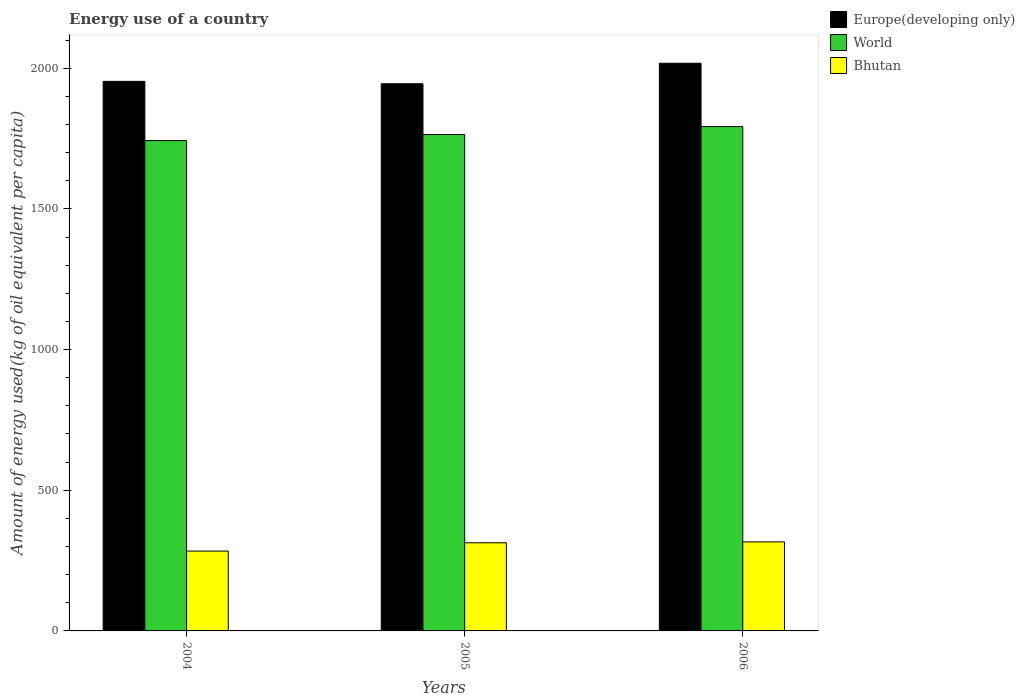How many different coloured bars are there?
Make the answer very short. 3. Are the number of bars on each tick of the X-axis equal?
Offer a very short reply. Yes. How many bars are there on the 1st tick from the right?
Provide a short and direct response. 3. What is the label of the 1st group of bars from the left?
Offer a terse response. 2004. In how many cases, is the number of bars for a given year not equal to the number of legend labels?
Your response must be concise. 0. What is the amount of energy used in in Europe(developing only) in 2005?
Your answer should be very brief. 1944.76. Across all years, what is the maximum amount of energy used in in World?
Your answer should be compact. 1792.57. Across all years, what is the minimum amount of energy used in in Bhutan?
Offer a terse response. 283.81. In which year was the amount of energy used in in World maximum?
Your response must be concise. 2006. What is the total amount of energy used in in World in the graph?
Ensure brevity in your answer.  5299.55. What is the difference between the amount of energy used in in Europe(developing only) in 2004 and that in 2005?
Offer a very short reply. 8.48. What is the difference between the amount of energy used in in World in 2005 and the amount of energy used in in Europe(developing only) in 2006?
Your answer should be compact. -253.32. What is the average amount of energy used in in Bhutan per year?
Keep it short and to the point. 304.49. In the year 2005, what is the difference between the amount of energy used in in Europe(developing only) and amount of energy used in in Bhutan?
Make the answer very short. 1631.47. In how many years, is the amount of energy used in in Bhutan greater than 2000 kg?
Your answer should be very brief. 0. What is the ratio of the amount of energy used in in Bhutan in 2004 to that in 2006?
Provide a short and direct response. 0.9. Is the amount of energy used in in Bhutan in 2005 less than that in 2006?
Provide a succinct answer. Yes. Is the difference between the amount of energy used in in Europe(developing only) in 2004 and 2006 greater than the difference between the amount of energy used in in Bhutan in 2004 and 2006?
Offer a very short reply. No. What is the difference between the highest and the second highest amount of energy used in in World?
Your response must be concise. 28.32. What is the difference between the highest and the lowest amount of energy used in in Europe(developing only)?
Offer a terse response. 72.82. What does the 3rd bar from the left in 2005 represents?
Your answer should be compact. Bhutan. Is it the case that in every year, the sum of the amount of energy used in in Europe(developing only) and amount of energy used in in Bhutan is greater than the amount of energy used in in World?
Offer a terse response. Yes. How many bars are there?
Provide a short and direct response. 9. What is the difference between two consecutive major ticks on the Y-axis?
Your answer should be very brief. 500. Are the values on the major ticks of Y-axis written in scientific E-notation?
Make the answer very short. No. Does the graph contain any zero values?
Keep it short and to the point. No. Does the graph contain grids?
Ensure brevity in your answer.  No. Where does the legend appear in the graph?
Your answer should be compact. Top right. How many legend labels are there?
Your response must be concise. 3. What is the title of the graph?
Give a very brief answer. Energy use of a country. What is the label or title of the X-axis?
Your answer should be very brief. Years. What is the label or title of the Y-axis?
Your answer should be very brief. Amount of energy used(kg of oil equivalent per capita). What is the Amount of energy used(kg of oil equivalent per capita) of Europe(developing only) in 2004?
Your response must be concise. 1953.24. What is the Amount of energy used(kg of oil equivalent per capita) in World in 2004?
Your answer should be compact. 1742.71. What is the Amount of energy used(kg of oil equivalent per capita) in Bhutan in 2004?
Ensure brevity in your answer.  283.81. What is the Amount of energy used(kg of oil equivalent per capita) of Europe(developing only) in 2005?
Keep it short and to the point. 1944.76. What is the Amount of energy used(kg of oil equivalent per capita) of World in 2005?
Ensure brevity in your answer.  1764.26. What is the Amount of energy used(kg of oil equivalent per capita) in Bhutan in 2005?
Keep it short and to the point. 313.29. What is the Amount of energy used(kg of oil equivalent per capita) in Europe(developing only) in 2006?
Your response must be concise. 2017.58. What is the Amount of energy used(kg of oil equivalent per capita) in World in 2006?
Your response must be concise. 1792.57. What is the Amount of energy used(kg of oil equivalent per capita) of Bhutan in 2006?
Provide a succinct answer. 316.38. Across all years, what is the maximum Amount of energy used(kg of oil equivalent per capita) in Europe(developing only)?
Make the answer very short. 2017.58. Across all years, what is the maximum Amount of energy used(kg of oil equivalent per capita) in World?
Your answer should be compact. 1792.57. Across all years, what is the maximum Amount of energy used(kg of oil equivalent per capita) in Bhutan?
Provide a succinct answer. 316.38. Across all years, what is the minimum Amount of energy used(kg of oil equivalent per capita) of Europe(developing only)?
Make the answer very short. 1944.76. Across all years, what is the minimum Amount of energy used(kg of oil equivalent per capita) of World?
Provide a succinct answer. 1742.71. Across all years, what is the minimum Amount of energy used(kg of oil equivalent per capita) of Bhutan?
Make the answer very short. 283.81. What is the total Amount of energy used(kg of oil equivalent per capita) in Europe(developing only) in the graph?
Your response must be concise. 5915.57. What is the total Amount of energy used(kg of oil equivalent per capita) of World in the graph?
Keep it short and to the point. 5299.55. What is the total Amount of energy used(kg of oil equivalent per capita) in Bhutan in the graph?
Give a very brief answer. 913.47. What is the difference between the Amount of energy used(kg of oil equivalent per capita) in Europe(developing only) in 2004 and that in 2005?
Your answer should be very brief. 8.48. What is the difference between the Amount of energy used(kg of oil equivalent per capita) of World in 2004 and that in 2005?
Offer a terse response. -21.54. What is the difference between the Amount of energy used(kg of oil equivalent per capita) of Bhutan in 2004 and that in 2005?
Keep it short and to the point. -29.48. What is the difference between the Amount of energy used(kg of oil equivalent per capita) in Europe(developing only) in 2004 and that in 2006?
Make the answer very short. -64.34. What is the difference between the Amount of energy used(kg of oil equivalent per capita) in World in 2004 and that in 2006?
Ensure brevity in your answer.  -49.86. What is the difference between the Amount of energy used(kg of oil equivalent per capita) of Bhutan in 2004 and that in 2006?
Make the answer very short. -32.57. What is the difference between the Amount of energy used(kg of oil equivalent per capita) of Europe(developing only) in 2005 and that in 2006?
Your answer should be very brief. -72.82. What is the difference between the Amount of energy used(kg of oil equivalent per capita) of World in 2005 and that in 2006?
Ensure brevity in your answer.  -28.32. What is the difference between the Amount of energy used(kg of oil equivalent per capita) in Bhutan in 2005 and that in 2006?
Ensure brevity in your answer.  -3.09. What is the difference between the Amount of energy used(kg of oil equivalent per capita) in Europe(developing only) in 2004 and the Amount of energy used(kg of oil equivalent per capita) in World in 2005?
Offer a terse response. 188.98. What is the difference between the Amount of energy used(kg of oil equivalent per capita) of Europe(developing only) in 2004 and the Amount of energy used(kg of oil equivalent per capita) of Bhutan in 2005?
Ensure brevity in your answer.  1639.95. What is the difference between the Amount of energy used(kg of oil equivalent per capita) in World in 2004 and the Amount of energy used(kg of oil equivalent per capita) in Bhutan in 2005?
Your answer should be very brief. 1429.43. What is the difference between the Amount of energy used(kg of oil equivalent per capita) of Europe(developing only) in 2004 and the Amount of energy used(kg of oil equivalent per capita) of World in 2006?
Provide a short and direct response. 160.66. What is the difference between the Amount of energy used(kg of oil equivalent per capita) in Europe(developing only) in 2004 and the Amount of energy used(kg of oil equivalent per capita) in Bhutan in 2006?
Offer a very short reply. 1636.86. What is the difference between the Amount of energy used(kg of oil equivalent per capita) of World in 2004 and the Amount of energy used(kg of oil equivalent per capita) of Bhutan in 2006?
Keep it short and to the point. 1426.33. What is the difference between the Amount of energy used(kg of oil equivalent per capita) in Europe(developing only) in 2005 and the Amount of energy used(kg of oil equivalent per capita) in World in 2006?
Offer a very short reply. 152.18. What is the difference between the Amount of energy used(kg of oil equivalent per capita) of Europe(developing only) in 2005 and the Amount of energy used(kg of oil equivalent per capita) of Bhutan in 2006?
Give a very brief answer. 1628.38. What is the difference between the Amount of energy used(kg of oil equivalent per capita) of World in 2005 and the Amount of energy used(kg of oil equivalent per capita) of Bhutan in 2006?
Provide a succinct answer. 1447.88. What is the average Amount of energy used(kg of oil equivalent per capita) in Europe(developing only) per year?
Offer a very short reply. 1971.86. What is the average Amount of energy used(kg of oil equivalent per capita) in World per year?
Give a very brief answer. 1766.52. What is the average Amount of energy used(kg of oil equivalent per capita) in Bhutan per year?
Give a very brief answer. 304.49. In the year 2004, what is the difference between the Amount of energy used(kg of oil equivalent per capita) in Europe(developing only) and Amount of energy used(kg of oil equivalent per capita) in World?
Give a very brief answer. 210.53. In the year 2004, what is the difference between the Amount of energy used(kg of oil equivalent per capita) of Europe(developing only) and Amount of energy used(kg of oil equivalent per capita) of Bhutan?
Keep it short and to the point. 1669.43. In the year 2004, what is the difference between the Amount of energy used(kg of oil equivalent per capita) of World and Amount of energy used(kg of oil equivalent per capita) of Bhutan?
Your answer should be very brief. 1458.91. In the year 2005, what is the difference between the Amount of energy used(kg of oil equivalent per capita) of Europe(developing only) and Amount of energy used(kg of oil equivalent per capita) of World?
Your answer should be compact. 180.5. In the year 2005, what is the difference between the Amount of energy used(kg of oil equivalent per capita) in Europe(developing only) and Amount of energy used(kg of oil equivalent per capita) in Bhutan?
Keep it short and to the point. 1631.47. In the year 2005, what is the difference between the Amount of energy used(kg of oil equivalent per capita) of World and Amount of energy used(kg of oil equivalent per capita) of Bhutan?
Make the answer very short. 1450.97. In the year 2006, what is the difference between the Amount of energy used(kg of oil equivalent per capita) of Europe(developing only) and Amount of energy used(kg of oil equivalent per capita) of World?
Provide a succinct answer. 225. In the year 2006, what is the difference between the Amount of energy used(kg of oil equivalent per capita) in Europe(developing only) and Amount of energy used(kg of oil equivalent per capita) in Bhutan?
Ensure brevity in your answer.  1701.2. In the year 2006, what is the difference between the Amount of energy used(kg of oil equivalent per capita) in World and Amount of energy used(kg of oil equivalent per capita) in Bhutan?
Your answer should be very brief. 1476.2. What is the ratio of the Amount of energy used(kg of oil equivalent per capita) in Europe(developing only) in 2004 to that in 2005?
Offer a terse response. 1. What is the ratio of the Amount of energy used(kg of oil equivalent per capita) in Bhutan in 2004 to that in 2005?
Your answer should be compact. 0.91. What is the ratio of the Amount of energy used(kg of oil equivalent per capita) of Europe(developing only) in 2004 to that in 2006?
Give a very brief answer. 0.97. What is the ratio of the Amount of energy used(kg of oil equivalent per capita) of World in 2004 to that in 2006?
Offer a very short reply. 0.97. What is the ratio of the Amount of energy used(kg of oil equivalent per capita) of Bhutan in 2004 to that in 2006?
Offer a very short reply. 0.9. What is the ratio of the Amount of energy used(kg of oil equivalent per capita) in Europe(developing only) in 2005 to that in 2006?
Your response must be concise. 0.96. What is the ratio of the Amount of energy used(kg of oil equivalent per capita) in World in 2005 to that in 2006?
Offer a very short reply. 0.98. What is the ratio of the Amount of energy used(kg of oil equivalent per capita) in Bhutan in 2005 to that in 2006?
Your answer should be compact. 0.99. What is the difference between the highest and the second highest Amount of energy used(kg of oil equivalent per capita) in Europe(developing only)?
Your response must be concise. 64.34. What is the difference between the highest and the second highest Amount of energy used(kg of oil equivalent per capita) of World?
Your answer should be very brief. 28.32. What is the difference between the highest and the second highest Amount of energy used(kg of oil equivalent per capita) in Bhutan?
Make the answer very short. 3.09. What is the difference between the highest and the lowest Amount of energy used(kg of oil equivalent per capita) in Europe(developing only)?
Make the answer very short. 72.82. What is the difference between the highest and the lowest Amount of energy used(kg of oil equivalent per capita) in World?
Give a very brief answer. 49.86. What is the difference between the highest and the lowest Amount of energy used(kg of oil equivalent per capita) in Bhutan?
Ensure brevity in your answer.  32.57. 